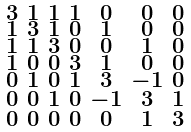Convert formula to latex. <formula><loc_0><loc_0><loc_500><loc_500>\begin{smallmatrix} 3 & 1 & 1 & 1 & 0 & 0 & 0 \\ 1 & 3 & 1 & 0 & 1 & 0 & 0 \\ 1 & 1 & 3 & 0 & 0 & 1 & 0 \\ 1 & 0 & 0 & 3 & 1 & 0 & 0 \\ 0 & 1 & 0 & 1 & 3 & - 1 & 0 \\ 0 & 0 & 1 & 0 & - 1 & 3 & 1 \\ 0 & 0 & 0 & 0 & 0 & 1 & 3 \end{smallmatrix}</formula> 